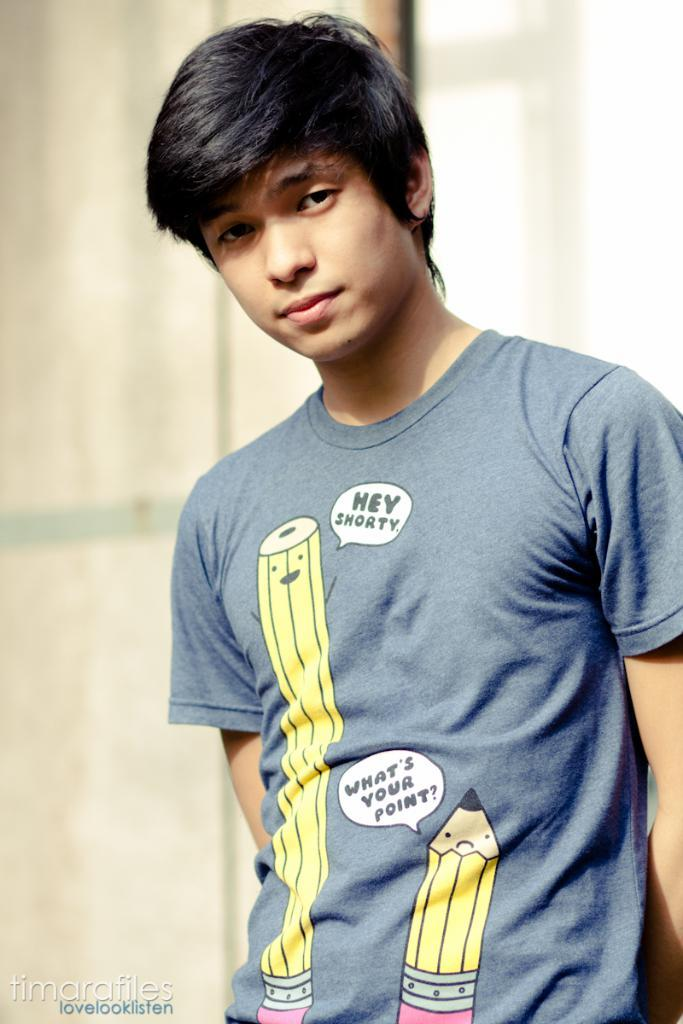<image>
Write a terse but informative summary of the picture. A teanager wearing a t-shirt with two pencils on it one says "hey shorty" the other says "what's your point?". 